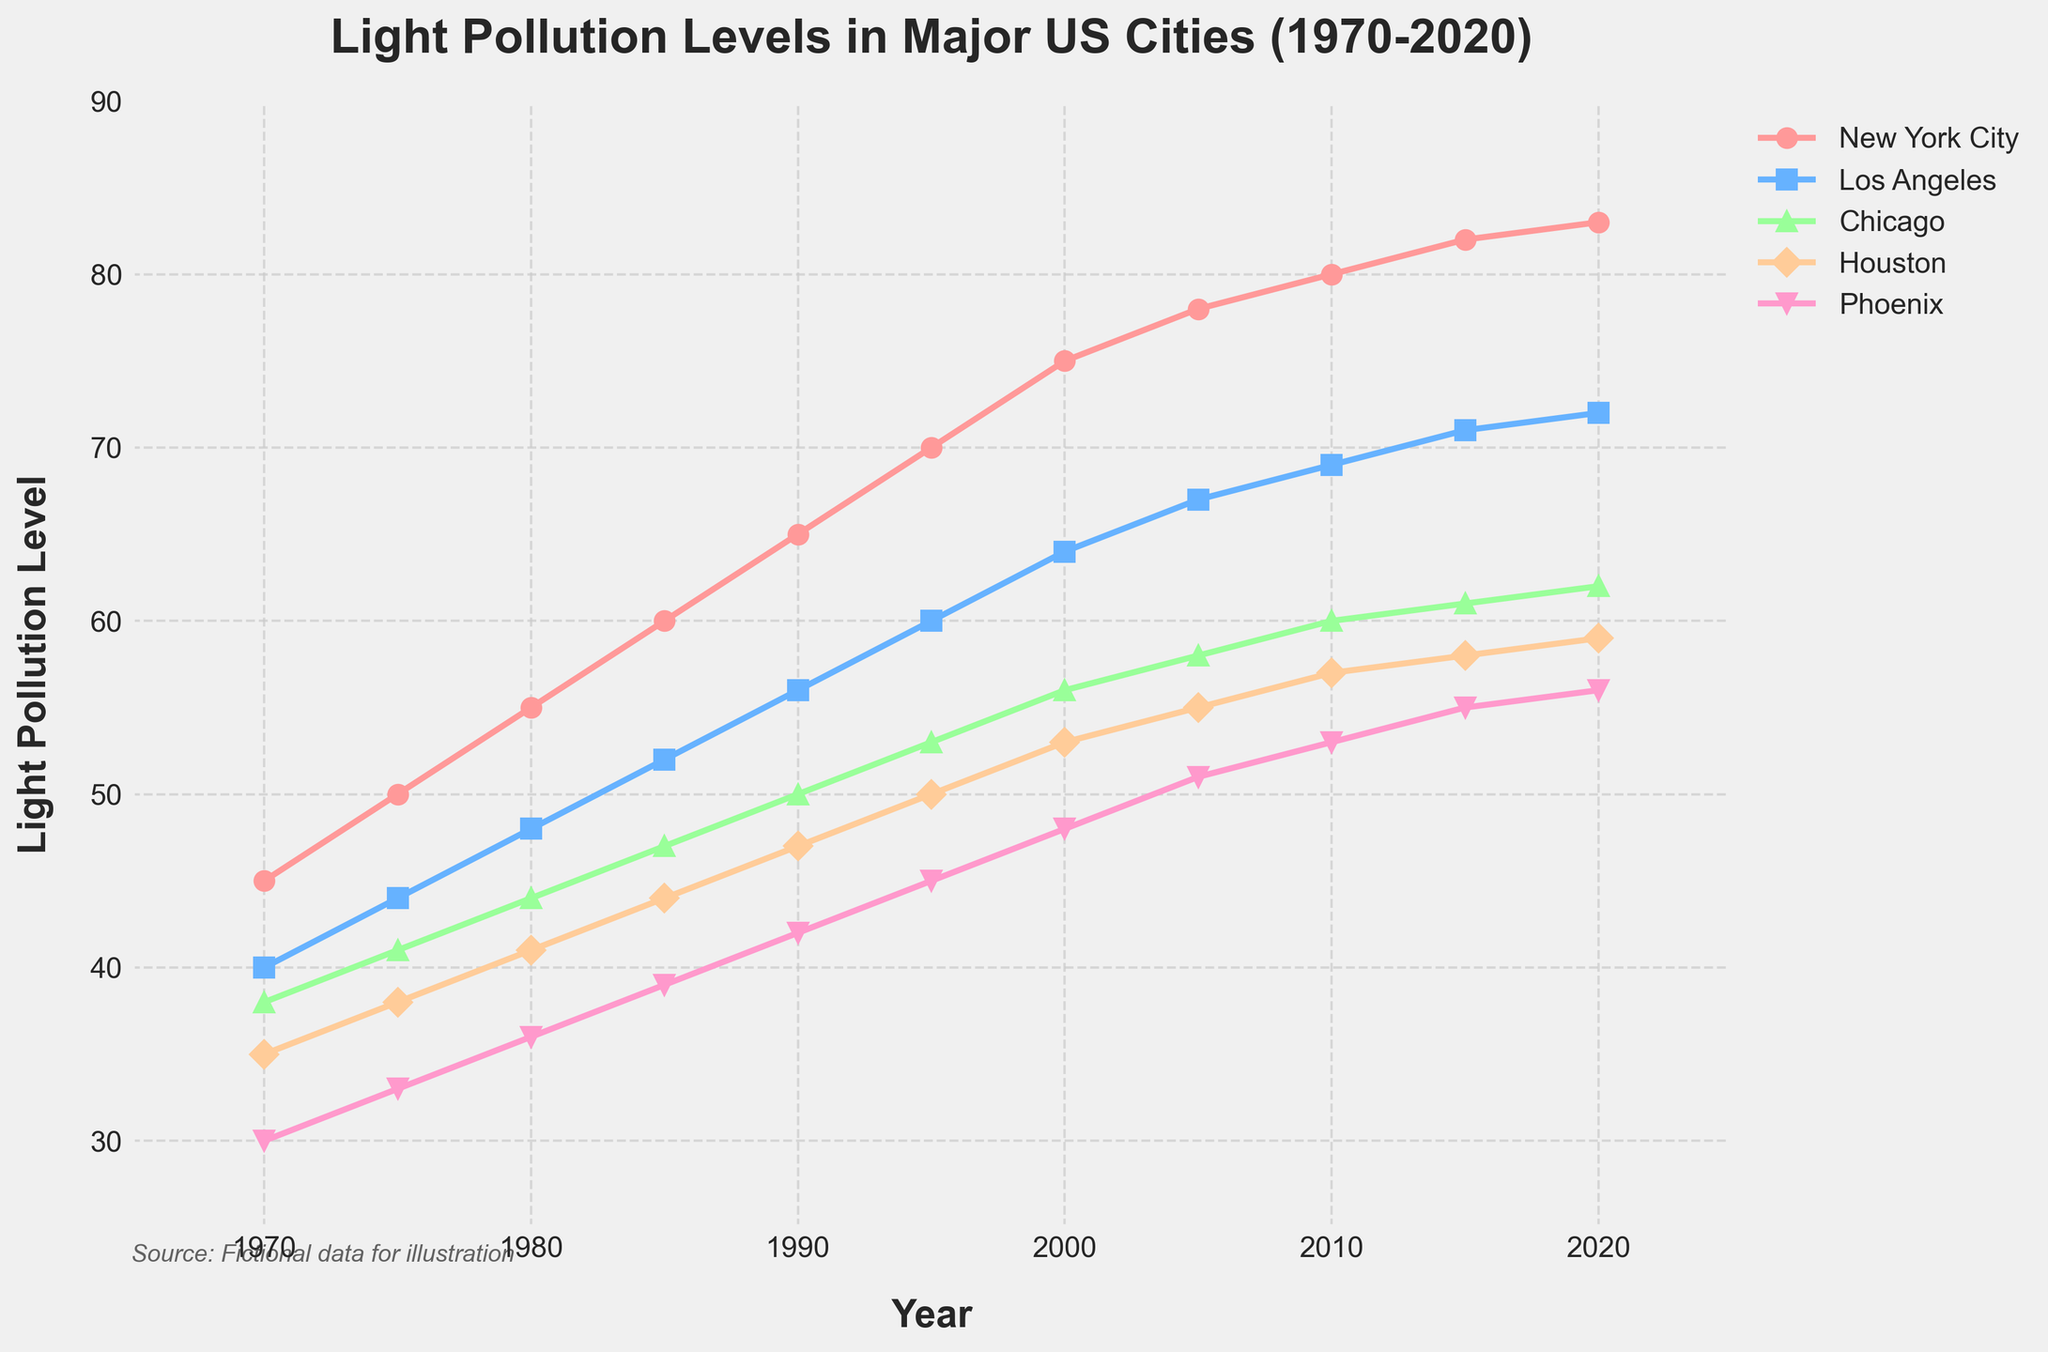What city had the highest light pollution level in 2020? The light pollution level for each city can be read off the chart for the year 2020. New York City has the highest light pollution level at 83.
Answer: New York City Which city had the fastest increase in light pollution from 1970 to 2020? To determine this, calculate the difference between the light pollution levels in 2020 and 1970 for each city, then compare these differences. New York City increased from 45 to 83, a difference of 38, which is the highest.
Answer: New York City Between 1990 and 2000, which city showed the smallest increase in light pollution levels? Calculate the difference in light pollution levels for each city between 1990 and 2000: New York City (10), Los Angeles (8), Chicago (6), Houston (6), Phoenix (6). Houston and Phoenix both show the smallest increase of 6.
Answer: Houston and Phoenix What was the average light pollution level across all cities in 1995? Sum the light pollution levels for all cities in 1995 and divide by the number of cities. (70 + 60 + 53 + 50 + 45) / 5 = 278 / 5 = 55.6
Answer: 55.6 In which year did Los Angeles exceed a light pollution level of 60? Trace the light pollution levels for Los Angeles over the years to find when it first exceeds 60. In the year 2000, Los Angeles reaches 64.
Answer: 2000 Which two cities had the closest light pollution levels in 2010, and what were those levels? Compare the light pollution levels for each city in 2010 to determine the smallest difference. Los Angeles (69) and Chicago (60) have the closest levels with a difference of 9.
Answer: Los Angeles and Chicago (69 and 60) By how much did the light pollution level in Houston increase from 1985 to 2015? Subtract the light pollution level in 1985 for Houston from that in 2015: 58 - 44 = 14.
Answer: 14 Which city had the least change in light pollution levels from 2015 to 2020? Calculate the difference in light pollution levels for each city from 2015 to 2020: New York City (1), Los Angeles (1), Chicago (1), Houston (1), Phoenix (1). All cities had the same smallest change of 1.
Answer: All cities What was the median light pollution level for Phoenix from 1970 to 2020? List the light pollution levels for Phoenix over the years (30, 33, 36, 39, 42, 45, 48, 51, 53, 55, 56) and find the middle value. The median value is 42.
Answer: 42 